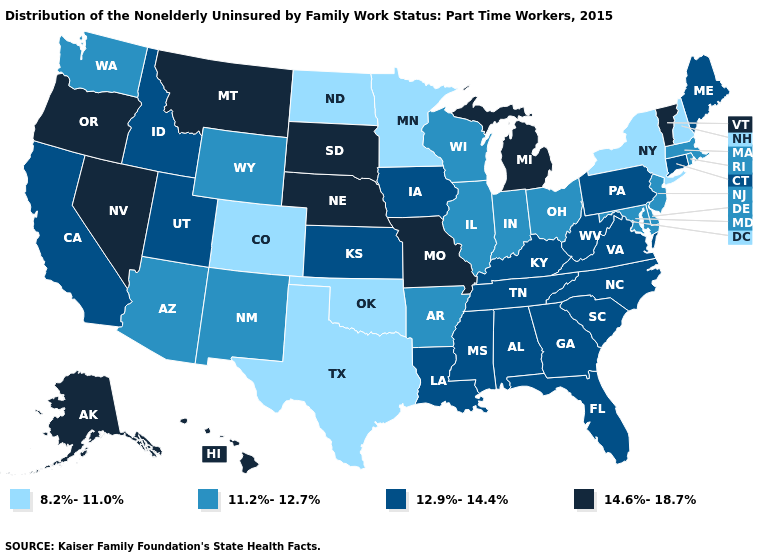Does Arizona have the same value as Massachusetts?
Give a very brief answer. Yes. What is the value of Virginia?
Keep it brief. 12.9%-14.4%. What is the highest value in the West ?
Write a very short answer. 14.6%-18.7%. What is the value of Maryland?
Quick response, please. 11.2%-12.7%. Is the legend a continuous bar?
Be succinct. No. What is the lowest value in states that border South Dakota?
Answer briefly. 8.2%-11.0%. What is the lowest value in the USA?
Give a very brief answer. 8.2%-11.0%. What is the value of Alabama?
Write a very short answer. 12.9%-14.4%. What is the value of Georgia?
Give a very brief answer. 12.9%-14.4%. What is the highest value in the Northeast ?
Quick response, please. 14.6%-18.7%. Does New Mexico have a lower value than Alabama?
Concise answer only. Yes. What is the value of Maryland?
Be succinct. 11.2%-12.7%. What is the value of Arizona?
Write a very short answer. 11.2%-12.7%. Name the states that have a value in the range 14.6%-18.7%?
Short answer required. Alaska, Hawaii, Michigan, Missouri, Montana, Nebraska, Nevada, Oregon, South Dakota, Vermont. What is the value of Kansas?
Write a very short answer. 12.9%-14.4%. 